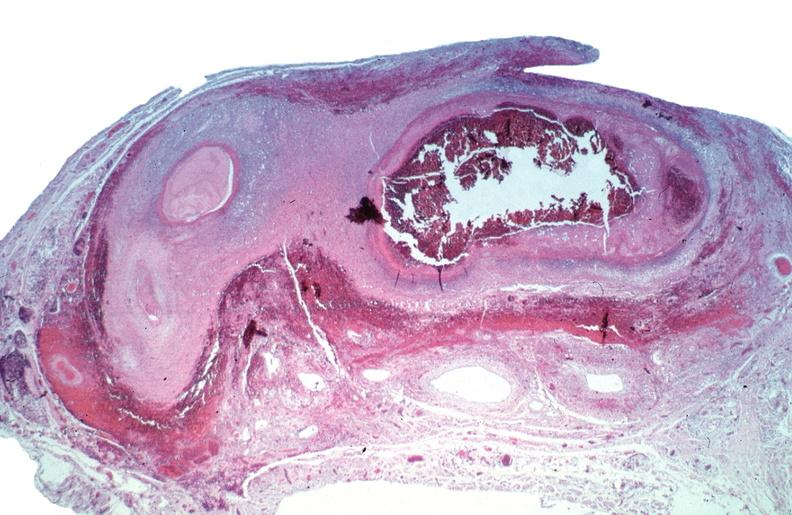s lymphangiomatosis present?
Answer the question using a single word or phrase. No 